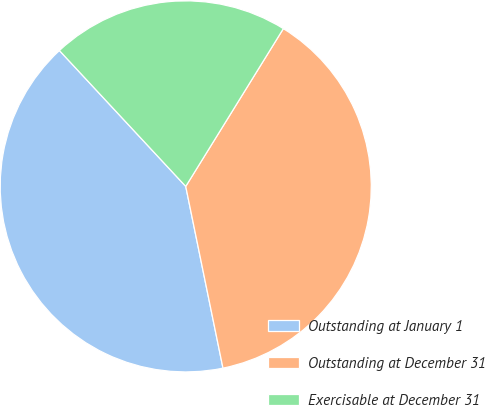Convert chart. <chart><loc_0><loc_0><loc_500><loc_500><pie_chart><fcel>Outstanding at January 1<fcel>Outstanding at December 31<fcel>Exercisable at December 31<nl><fcel>41.29%<fcel>37.96%<fcel>20.74%<nl></chart> 